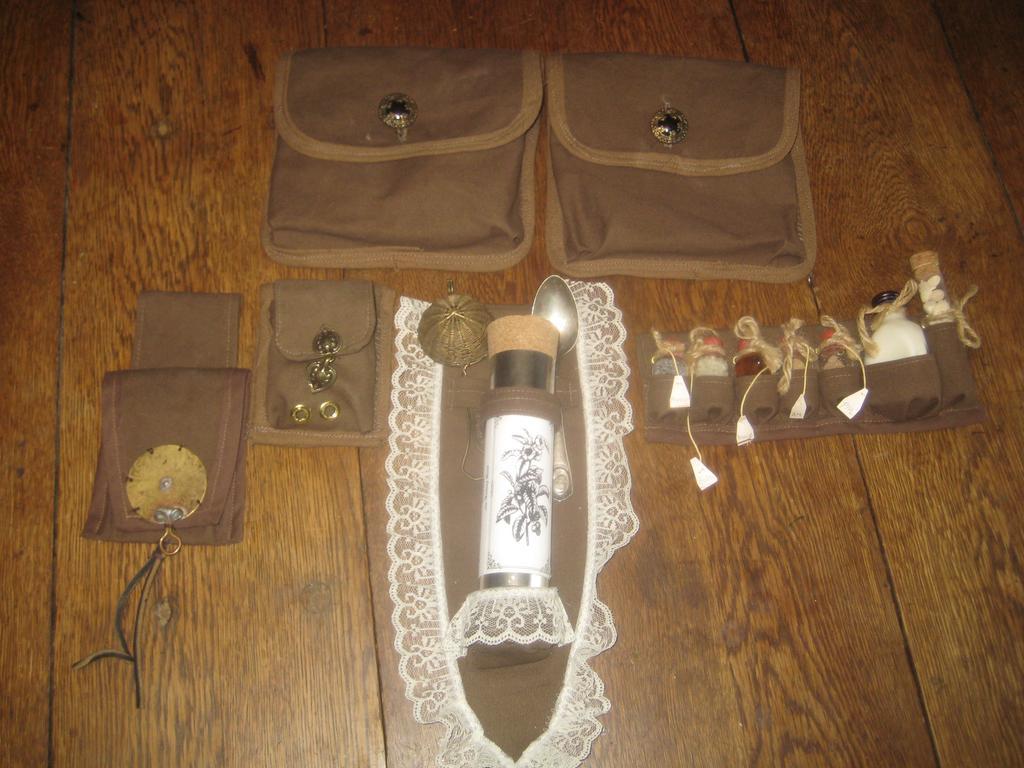Could you give a brief overview of what you see in this image? In this image we can see different types of brown color pockets are arranged on the wooden surface. 